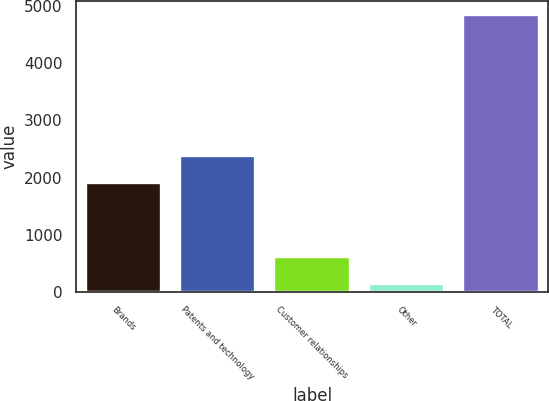<chart> <loc_0><loc_0><loc_500><loc_500><bar_chart><fcel>Brands<fcel>Patents and technology<fcel>Customer relationships<fcel>Other<fcel>TOTAL<nl><fcel>1898<fcel>2370.3<fcel>604.3<fcel>132<fcel>4855<nl></chart> 